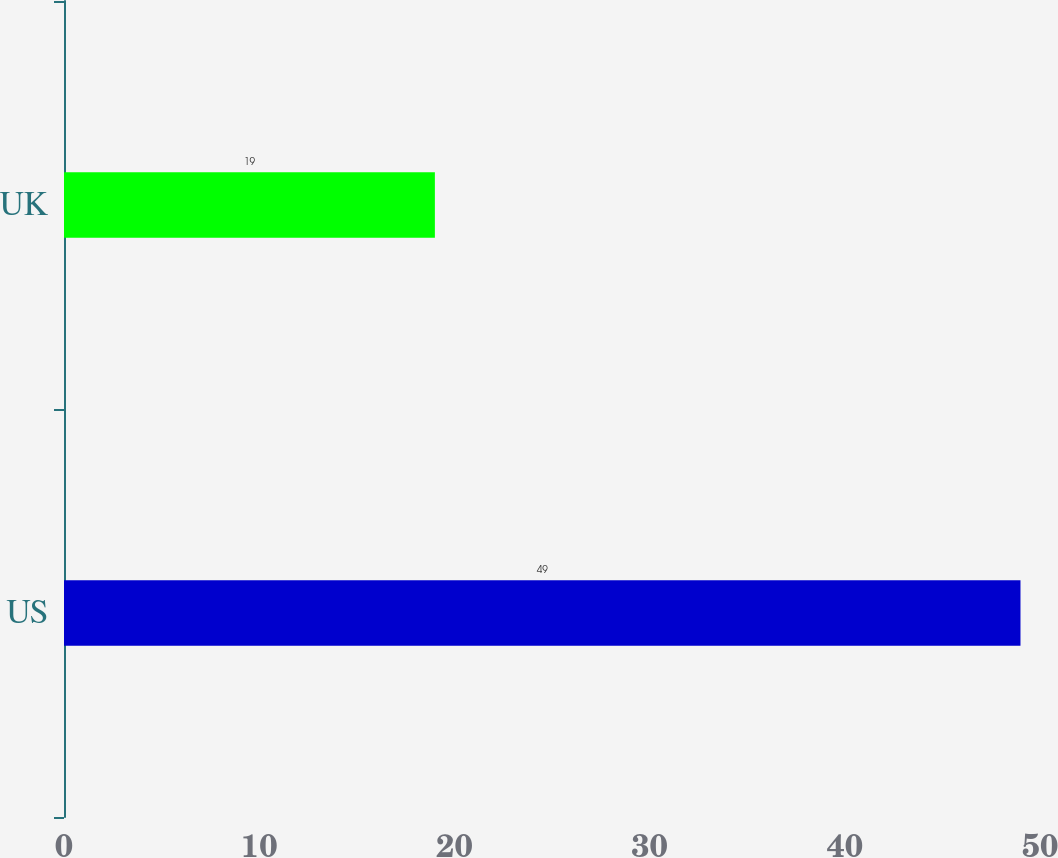Convert chart to OTSL. <chart><loc_0><loc_0><loc_500><loc_500><bar_chart><fcel>US<fcel>UK<nl><fcel>49<fcel>19<nl></chart> 